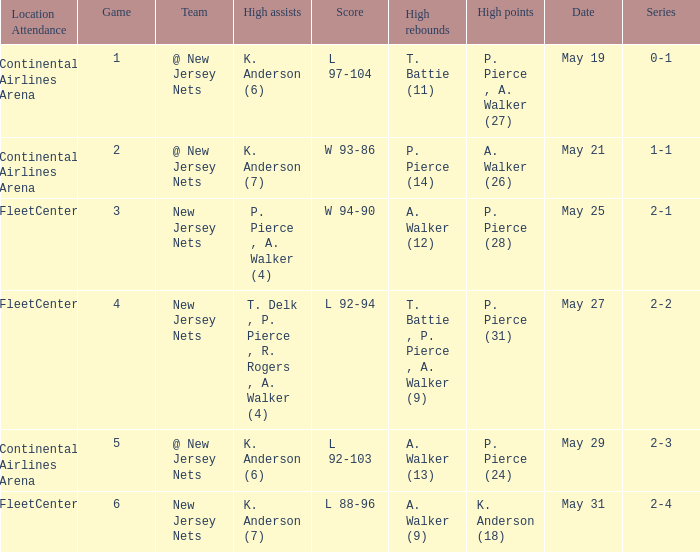What was the highest assists for game 3? P. Pierce , A. Walker (4). 